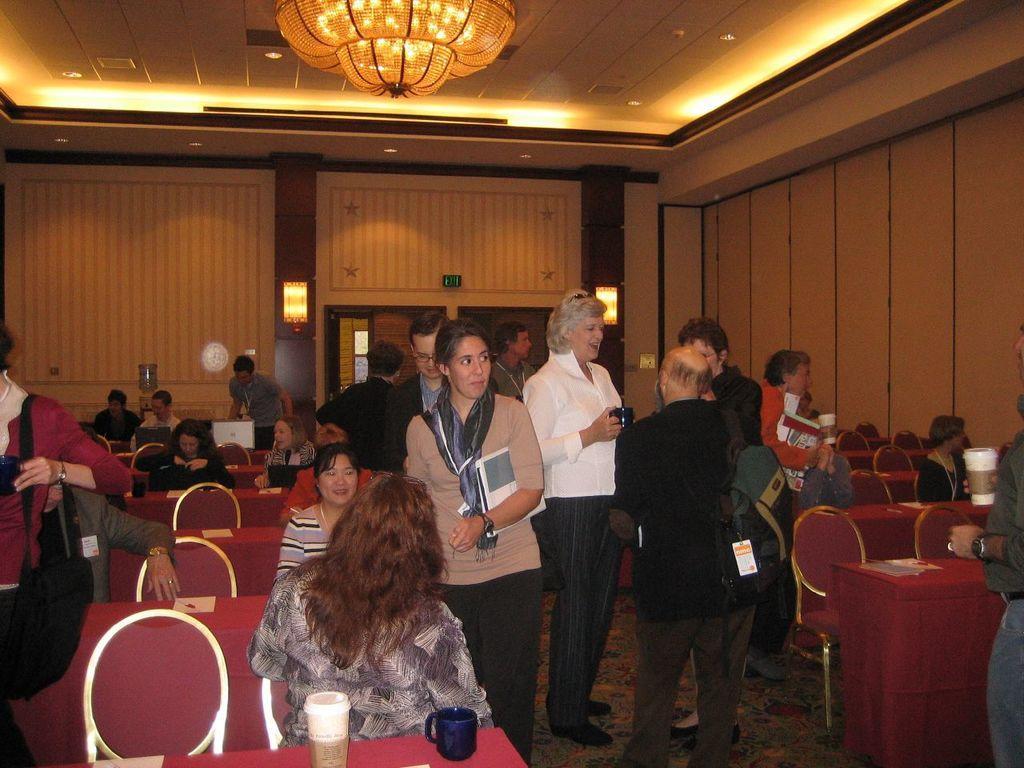Describe this image in one or two sentences. In the image we can see there are people who are sitting on chair and there few people are standing. 